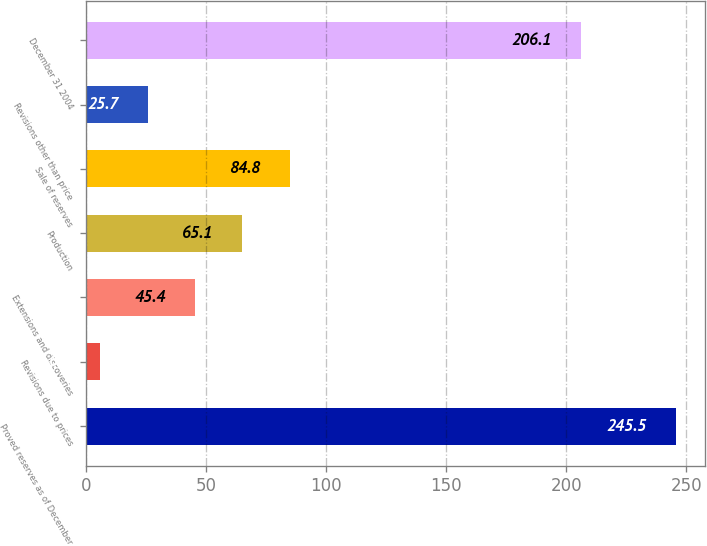Convert chart to OTSL. <chart><loc_0><loc_0><loc_500><loc_500><bar_chart><fcel>Proved reserves as of December<fcel>Revisions due to prices<fcel>Extensions and discoveries<fcel>Production<fcel>Sale of reserves<fcel>Revisions other than price<fcel>December 31 2004<nl><fcel>245.5<fcel>6<fcel>45.4<fcel>65.1<fcel>84.8<fcel>25.7<fcel>206.1<nl></chart> 